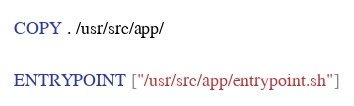<code> <loc_0><loc_0><loc_500><loc_500><_Dockerfile_>
COPY . /usr/src/app/

ENTRYPOINT ["/usr/src/app/entrypoint.sh"]</code> 